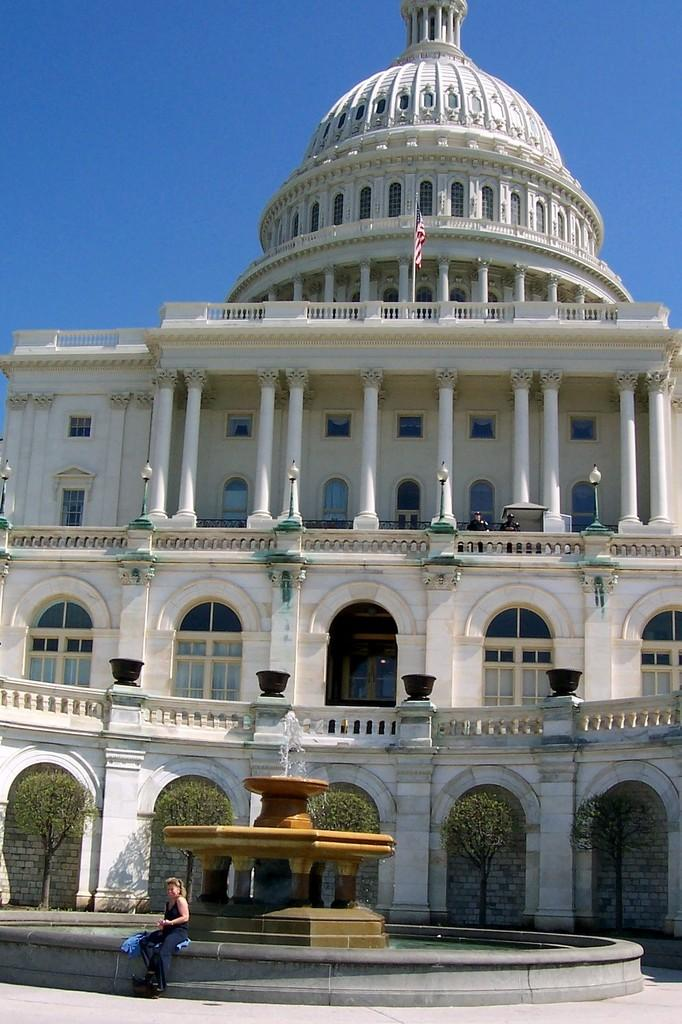Who is the main subject in the picture? There is a girl in the picture. What can be seen at the bottom of the image? There is a fountain at the bottom of the image. What type of vegetation is in the middle of the image? There are trees in the middle of the image. What is visible in the background of the image? There is a building in the background of the image. What is visible at the top of the image? The sky is visible at the top of the image. What type of appliance is being used by the girl in the image? There is no appliance visible in the image, and the girl is not using any appliance. What is the value of the trees in the middle of the image? The value of the trees cannot be determined from the image, as they are not for sale or have any monetary value associated with them in the context of the image. 